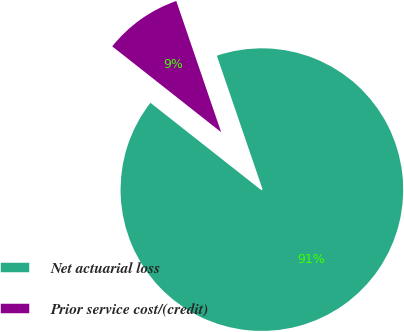Convert chart. <chart><loc_0><loc_0><loc_500><loc_500><pie_chart><fcel>Net actuarial loss<fcel>Prior service cost/(credit)<nl><fcel>90.87%<fcel>9.13%<nl></chart> 